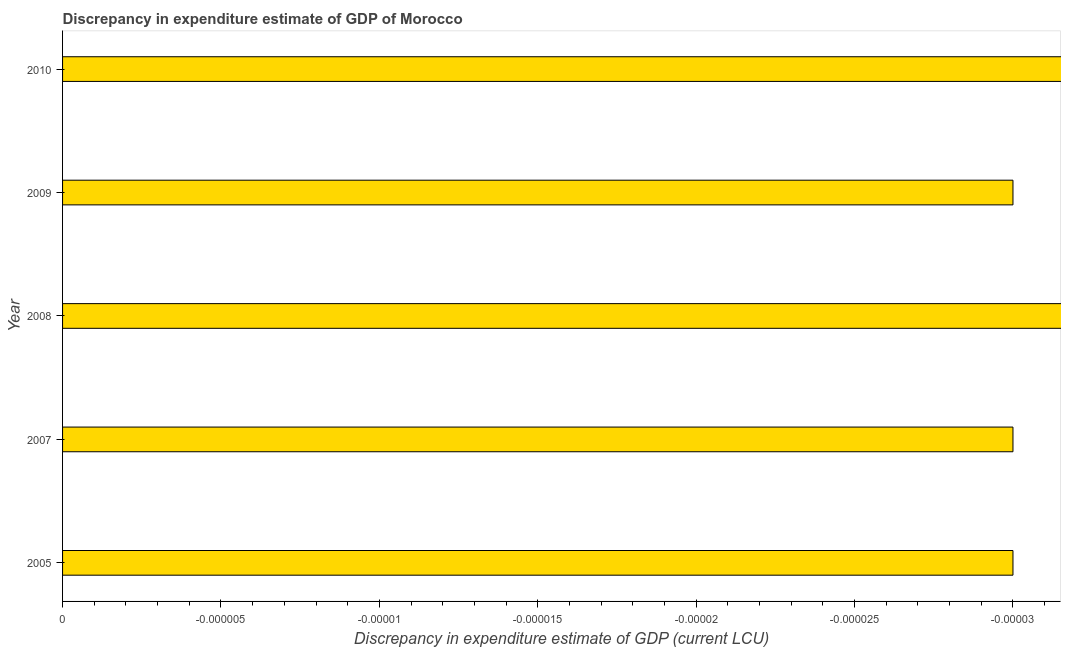What is the title of the graph?
Offer a terse response. Discrepancy in expenditure estimate of GDP of Morocco. What is the label or title of the X-axis?
Offer a very short reply. Discrepancy in expenditure estimate of GDP (current LCU). What is the label or title of the Y-axis?
Make the answer very short. Year. What is the median discrepancy in expenditure estimate of gdp?
Your response must be concise. 0. Are all the bars in the graph horizontal?
Give a very brief answer. Yes. What is the difference between two consecutive major ticks on the X-axis?
Your answer should be very brief. 4.9999999999999996e-6. Are the values on the major ticks of X-axis written in scientific E-notation?
Keep it short and to the point. No. What is the Discrepancy in expenditure estimate of GDP (current LCU) in 2008?
Your answer should be very brief. 0. What is the Discrepancy in expenditure estimate of GDP (current LCU) of 2009?
Keep it short and to the point. 0. What is the Discrepancy in expenditure estimate of GDP (current LCU) of 2010?
Offer a terse response. 0. 